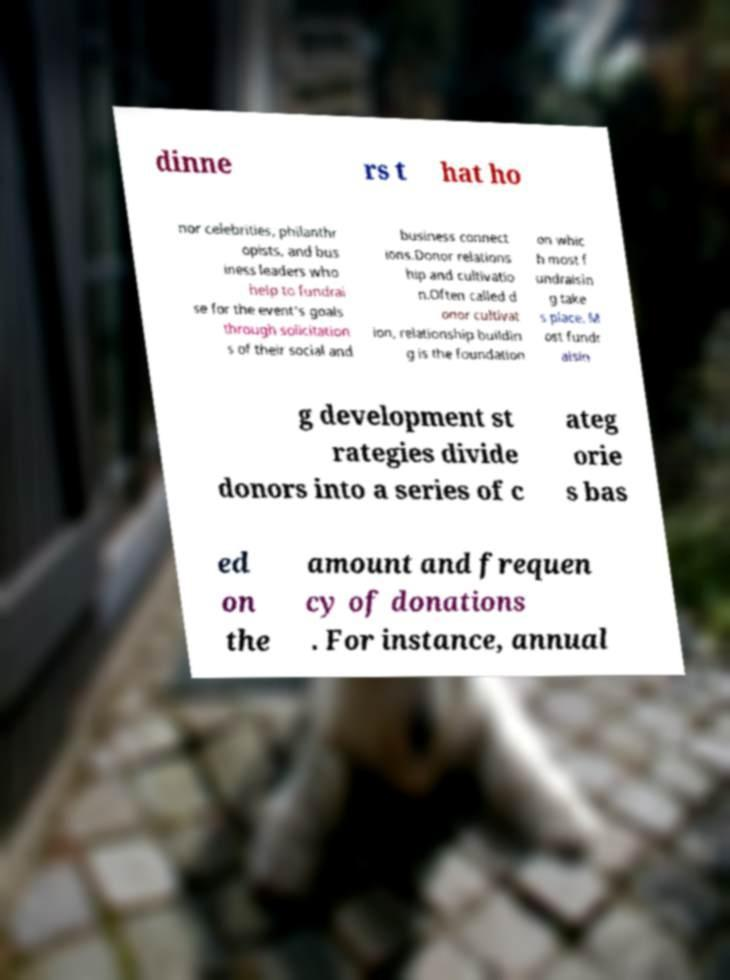Could you extract and type out the text from this image? dinne rs t hat ho nor celebrities, philanthr opists, and bus iness leaders who help to fundrai se for the event's goals through solicitation s of their social and business connect ions.Donor relations hip and cultivatio n.Often called d onor cultivat ion, relationship buildin g is the foundation on whic h most f undraisin g take s place. M ost fundr aisin g development st rategies divide donors into a series of c ateg orie s bas ed on the amount and frequen cy of donations . For instance, annual 